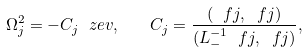<formula> <loc_0><loc_0><loc_500><loc_500>\Omega _ { j } ^ { 2 } = - C _ { j } \ z e v , \quad C _ { j } = \frac { ( \ f j , \ f j ) } { ( L _ { - } ^ { - 1 } \ f j , \ f j ) } ,</formula> 